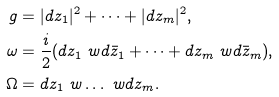<formula> <loc_0><loc_0><loc_500><loc_500>g & = | d z _ { 1 } | ^ { 2 } + \dots + | d z _ { m } | ^ { 2 } , \\ \omega & = \frac { i } { 2 } ( d z _ { 1 } \ w d \bar { z } _ { 1 } + \dots + d z _ { m } \ w d \bar { z } _ { m } ) , \\ \Omega & = d z _ { 1 } \ w \dots \ w d z _ { m } .</formula> 